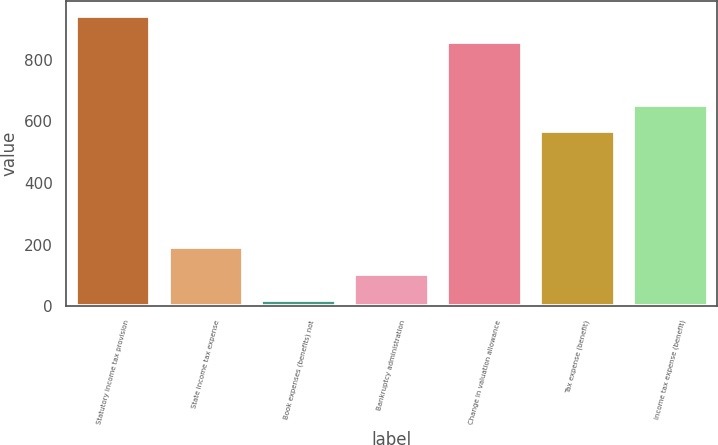Convert chart to OTSL. <chart><loc_0><loc_0><loc_500><loc_500><bar_chart><fcel>Statutory income tax provision<fcel>State income tax expense<fcel>Book expenses (benefits) not<fcel>Bankruptcy administration<fcel>Change in valuation allowance<fcel>Tax expense (benefit)<fcel>Income tax expense (benefit)<nl><fcel>943.3<fcel>190.6<fcel>20<fcel>105.3<fcel>858<fcel>569<fcel>654.3<nl></chart> 